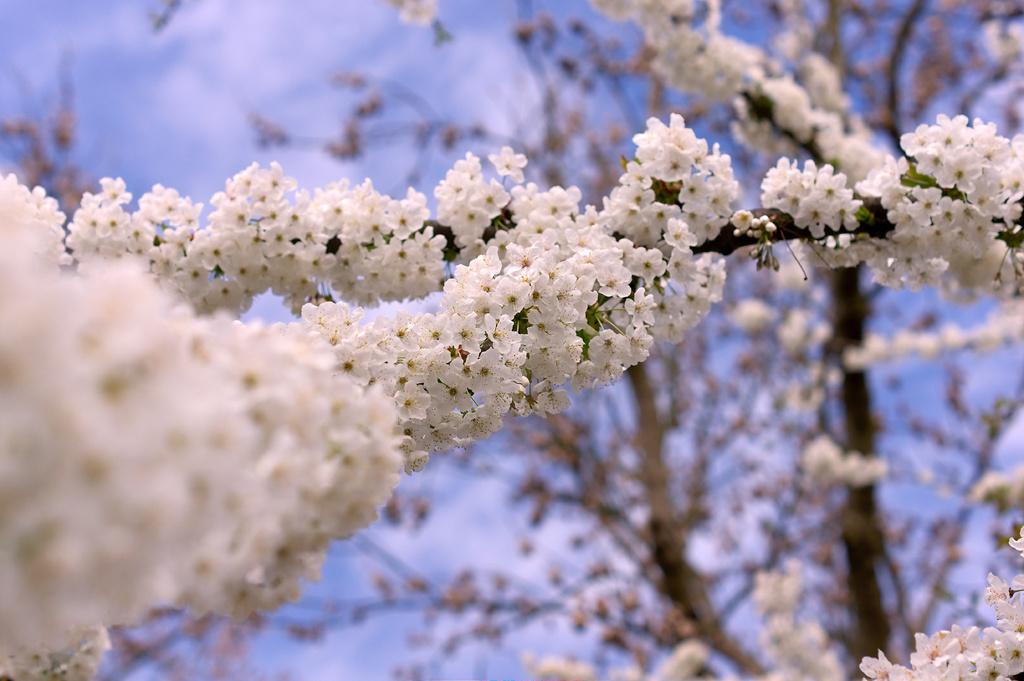What type of vegetation can be seen on a tree in the image? There are flowers on a tree in the image. What can be seen in the background of the image? There is a sky visible in the background of the image. What is present in the sky? There are clouds in the sky. What type of salt can be seen on the tree in the image? There is no salt present on the tree in the image; it features flowers instead. 